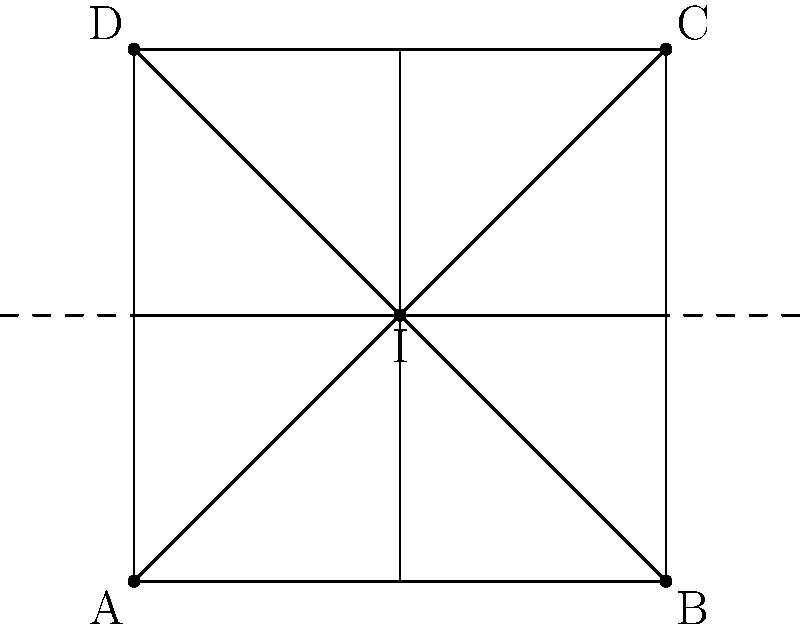A symmetrical design for a handbag is shown above. If the design is reflected across the dashed line, which point will coincide with point C after the reflection? To solve this problem, we need to understand the concept of reflection in transformational geometry:

1. In a reflection, each point of the original shape is mapped to a point that is the same distance from the line of reflection but on the opposite side.

2. The line of reflection acts as a mirror, creating a mirror image of the original shape.

3. Points on the line of reflection remain unchanged after reflection.

4. The distance of any point from the line of reflection is equal to the distance of its image from the line of reflection.

Now, let's analyze the given shape:

1. The dashed line is the line of reflection, which passes through the center of the square (point I).

2. Points A, B, C, and D form the vertices of the square.

3. The square is symmetrical, and the line of reflection divides it into two equal halves.

4. When reflected, point A will map to point B, and point D will map to point C.

5. Point C is the same distance from the line of reflection as point D, but on the opposite side.

Therefore, after reflection, point D will coincide with point C.
Answer: D 